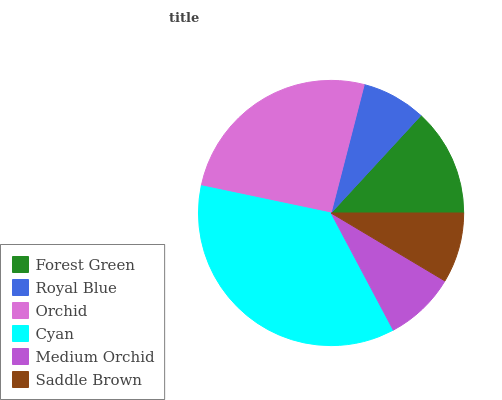Is Royal Blue the minimum?
Answer yes or no. Yes. Is Cyan the maximum?
Answer yes or no. Yes. Is Orchid the minimum?
Answer yes or no. No. Is Orchid the maximum?
Answer yes or no. No. Is Orchid greater than Royal Blue?
Answer yes or no. Yes. Is Royal Blue less than Orchid?
Answer yes or no. Yes. Is Royal Blue greater than Orchid?
Answer yes or no. No. Is Orchid less than Royal Blue?
Answer yes or no. No. Is Forest Green the high median?
Answer yes or no. Yes. Is Medium Orchid the low median?
Answer yes or no. Yes. Is Saddle Brown the high median?
Answer yes or no. No. Is Forest Green the low median?
Answer yes or no. No. 